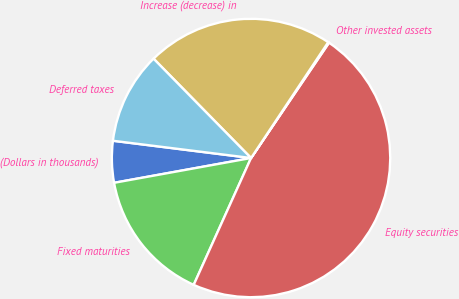Convert chart to OTSL. <chart><loc_0><loc_0><loc_500><loc_500><pie_chart><fcel>(Dollars in thousands)<fcel>Fixed maturities<fcel>Equity securities<fcel>Other invested assets<fcel>Increase (decrease) in<fcel>Deferred taxes<nl><fcel>4.83%<fcel>15.39%<fcel>47.29%<fcel>0.11%<fcel>21.7%<fcel>10.67%<nl></chart> 